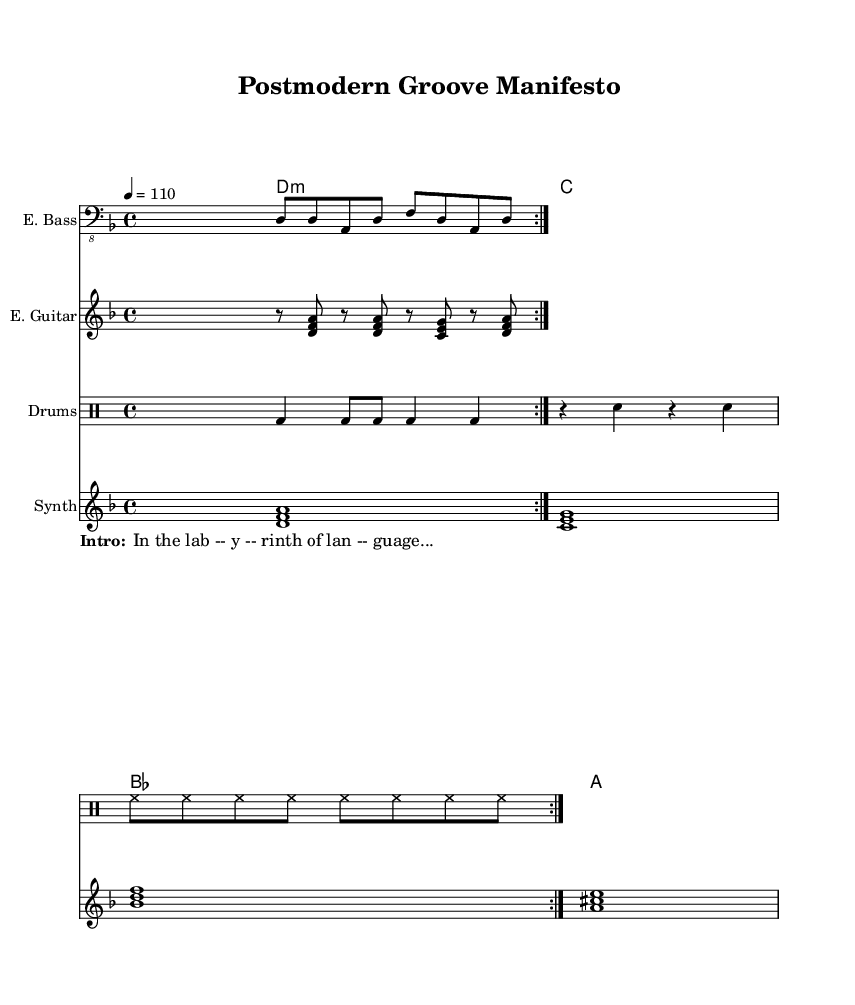What is the key signature of this music? The key signature is D minor, indicated at the beginning of the score. D minor has one flat, which is B flat.
Answer: D minor What is the time signature of this piece? The time signature is 4/4, shown at the beginning of the score, indicating four beats per measure.
Answer: 4/4 What is the tempo marking for the piece? The tempo is marked at 110 beats per minute, indicated near the beginning with the notation "4 = 110".
Answer: 110 How many measures are in the drum patterns section? The drum patterns section contains a repeated pattern that creates a total of 8 measures: 2 measures repeated with each pattern leading to a total of 4 repeated measures, and each measure contains a consistent rhythmic pattern.
Answer: 8 What sound is produced by the electric guitar during the first section? The electric guitar produces a mixture of rests and arpeggiated chords, specifically the chords D minor and C major, which are characteristic of funk music. These chords are played with rhythmic syncopation typical in funk.
Answer: Chords What literary element is incorporated into the spoken word section? The spoken word section contains a reference to a "labyrinth of language," suggesting complex themes often found in postmodern literature, intertwining the abstract concept of language with funk music.
Answer: Labyrinth What unique musical element do you notice in the spoken word introduction? The spoken word introduction appears as a contrasting element amidst the instrumental sections, serving to enhance the thematic depth and adding a narrative layer to the composition. This blending of spoken word with music is a hallmark of funk fusion.
Answer: Spoken word 